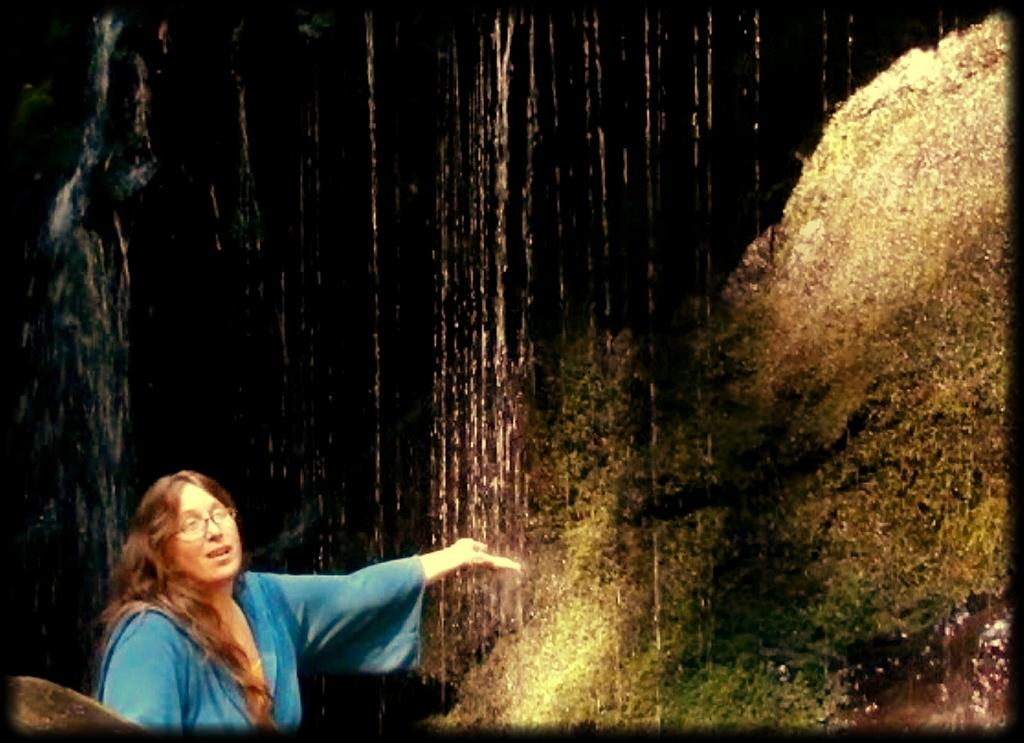Who is present in the image? There is a woman in the image. What is the woman wearing? The woman is wearing a blue dress. What is the background of the image? The woman is standing in front of a waterfall. What type of cheese is the woman holding in the image? There is no cheese present in the image; the woman is standing in front of a waterfall. 